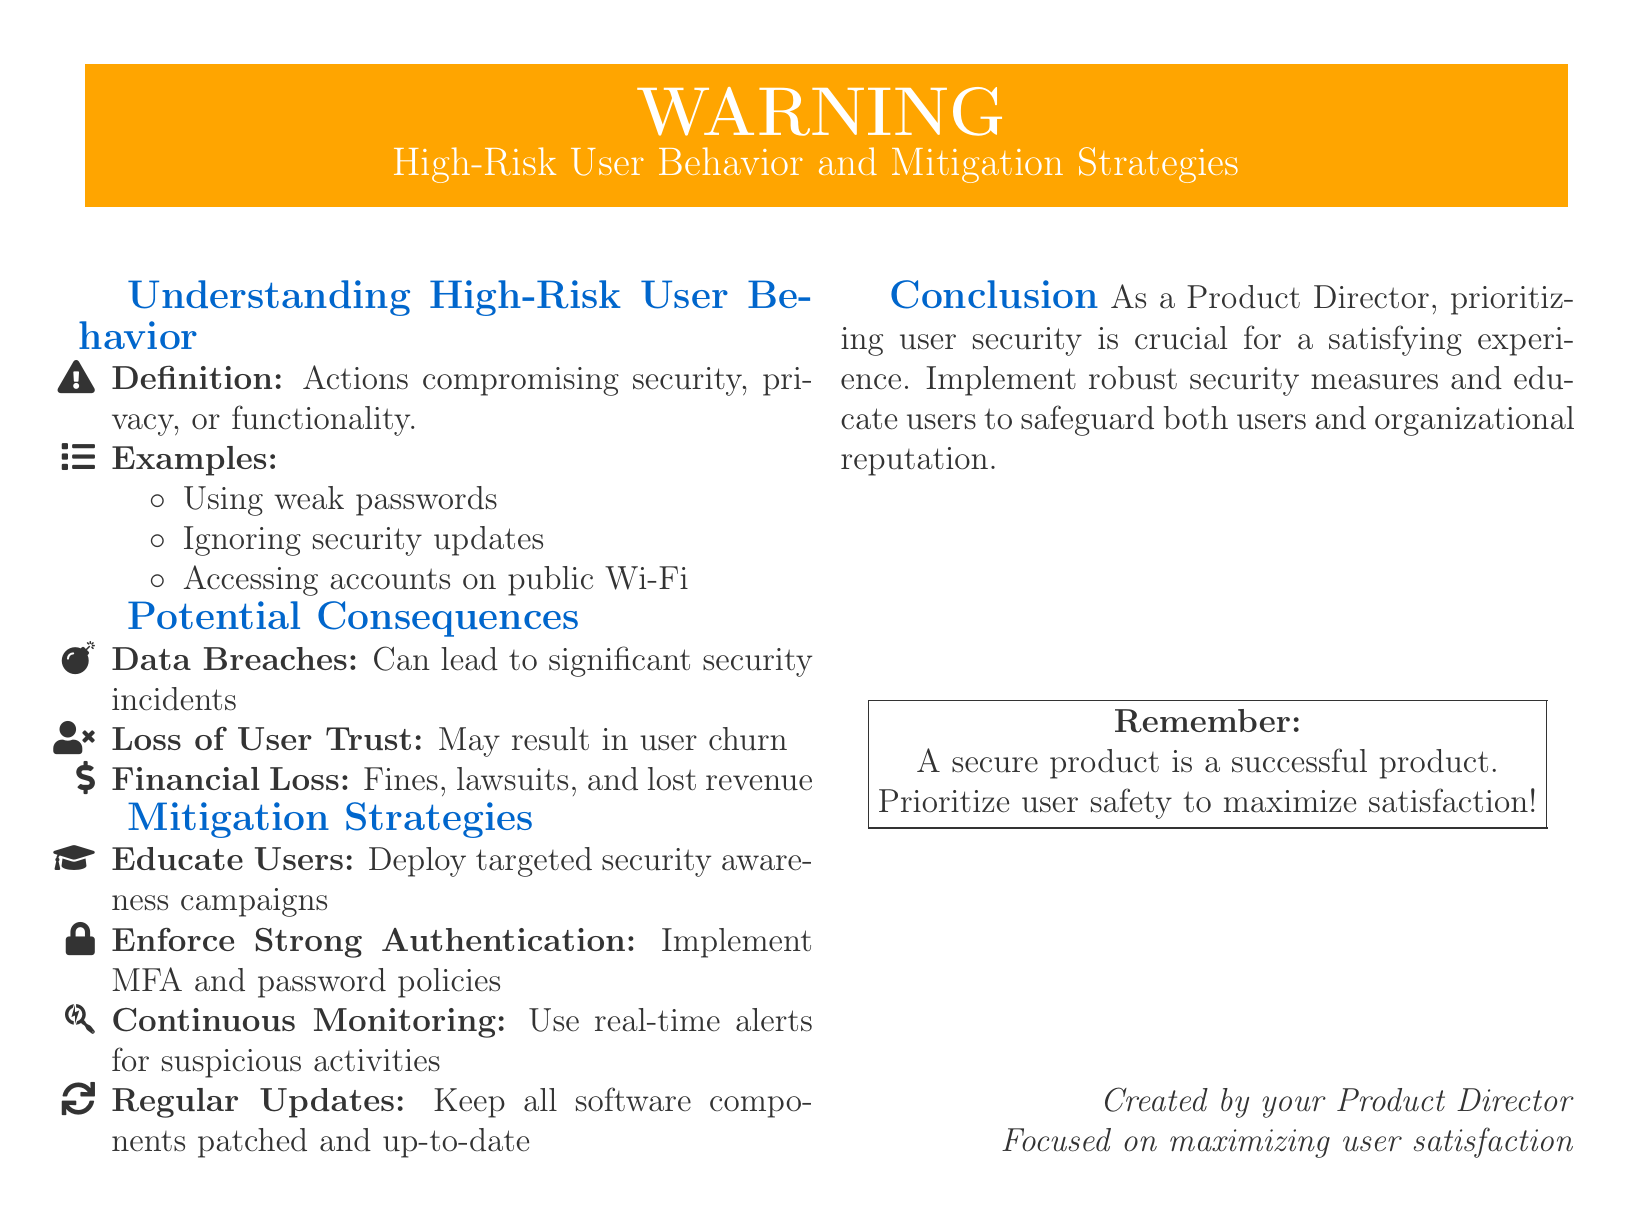What is the title of the warning? The title highlights the focus on user behavior and strategies to mitigate risks associated with it.
Answer: High-Risk User Behavior and Mitigation Strategies What are the potential consequences listed? The document outlines three main consequences related to high-risk user behavior as noted by specific icons.
Answer: Data Breaches, Loss of User Trust, Financial Loss What is one example of high-risk user behavior? The document provides several examples, one of which was clearly listed under the section on understanding high-risk behavior.
Answer: Using weak passwords What is a recommended mitigation strategy? The document suggests strategies to address user behavior risks; one such recommendation is directly mentioned.
Answer: Educate Users What color is used for the warning box? The color used for the warning box is specified in the document to attract attention.
Answer: Orange 